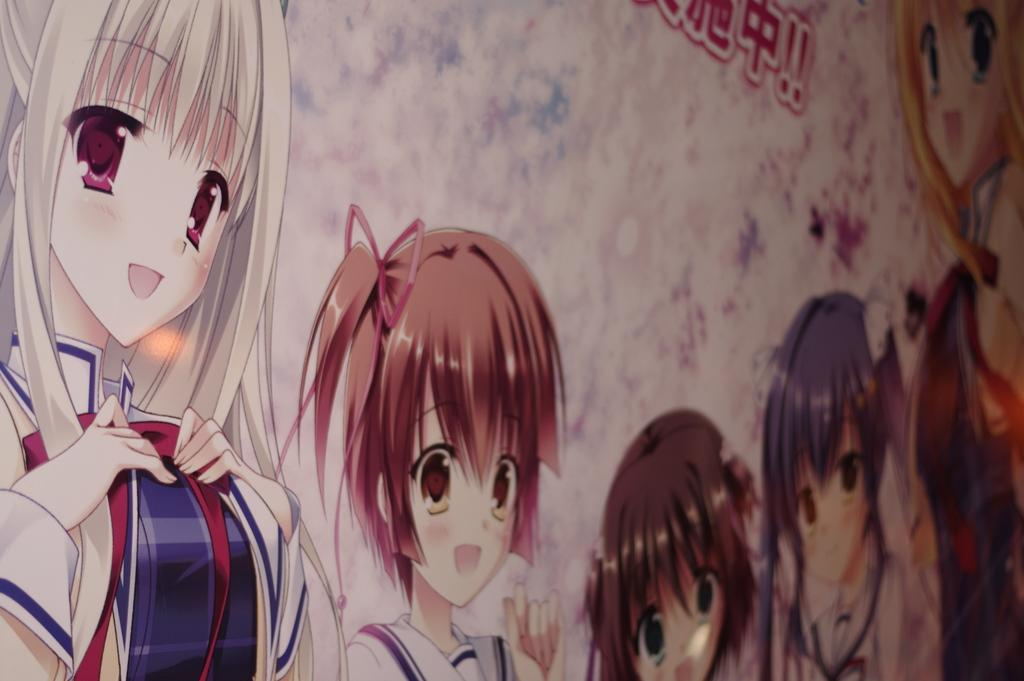What is depicted on the wall in the image? There is graffiti of persons on a wall in the image. How many matches are being used to light the graffiti in the image? There is no mention of matches or lighting in the image; it only shows graffiti of persons on a wall. What type of snakes can be seen slithering on the wall in the image? There are no snakes present in the image; it only features graffiti of persons on a wall. 